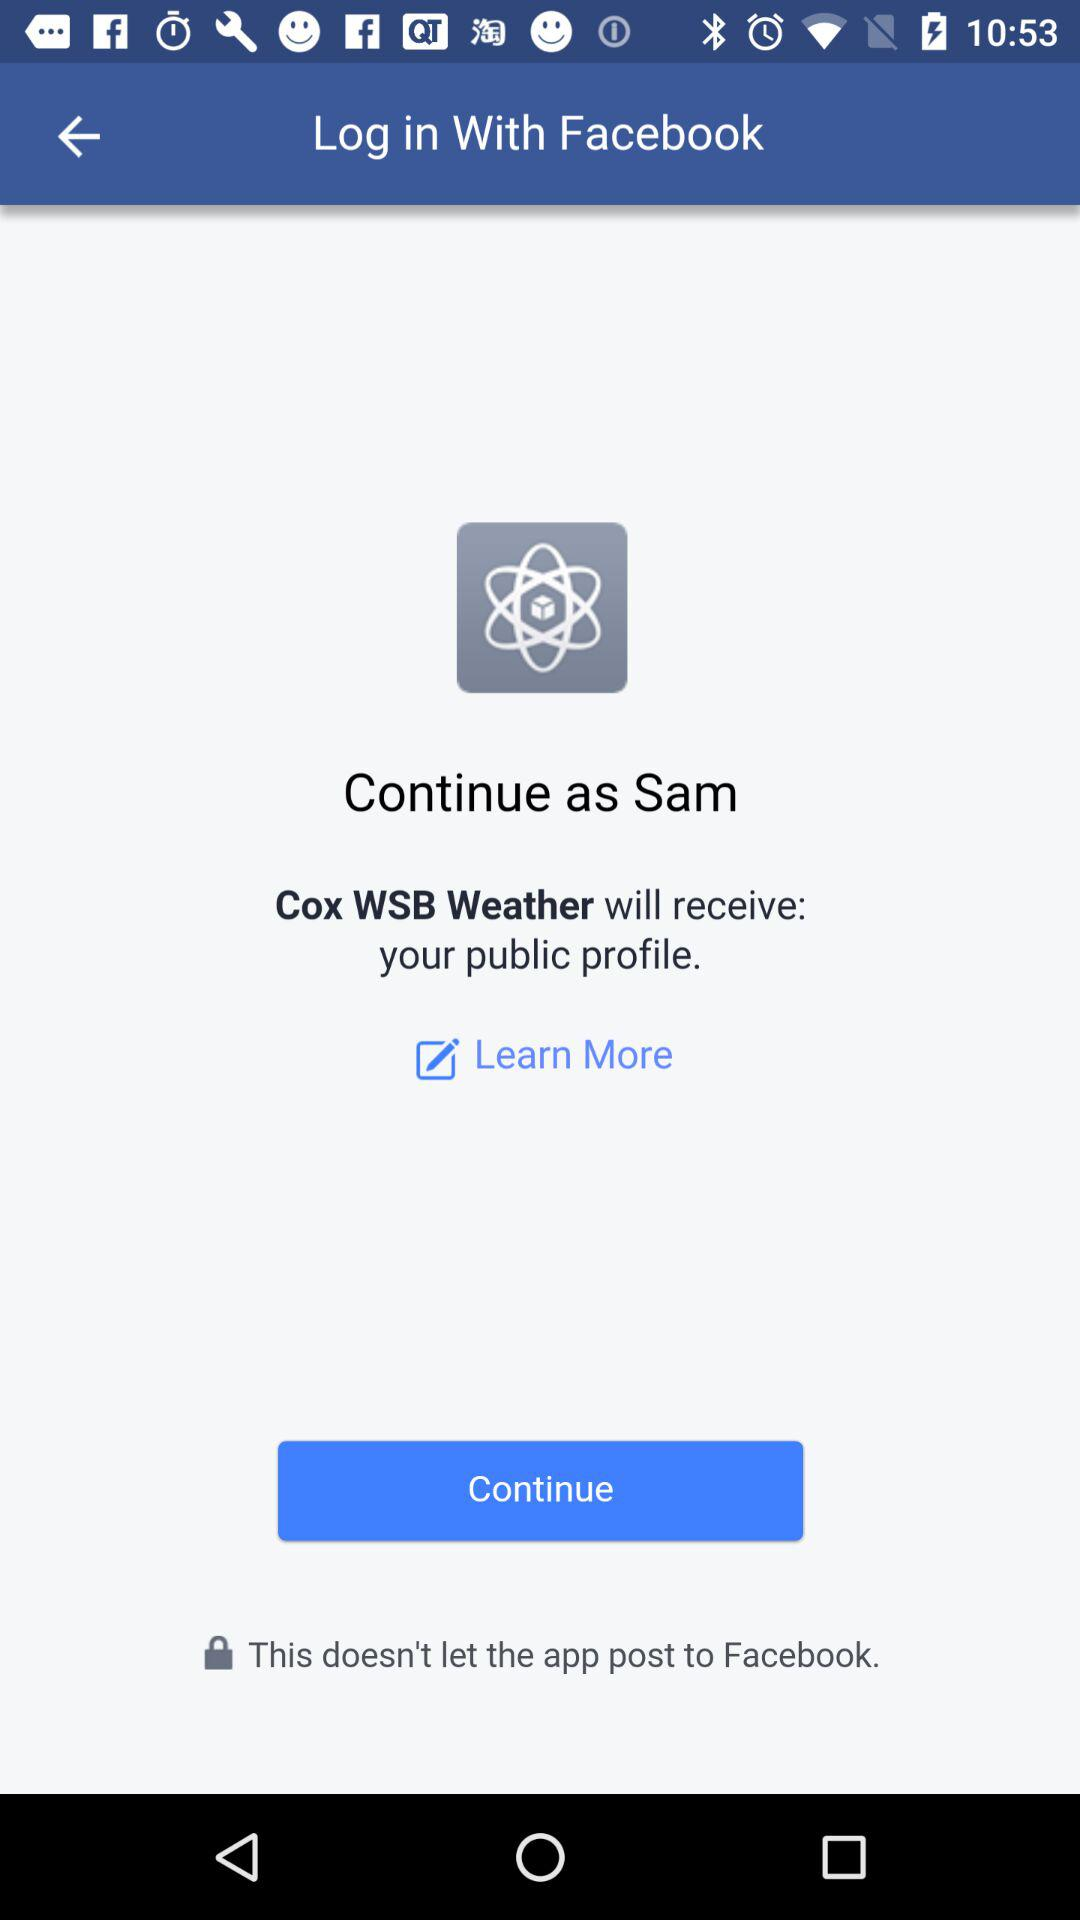What is the login name? The login name is Sam. 